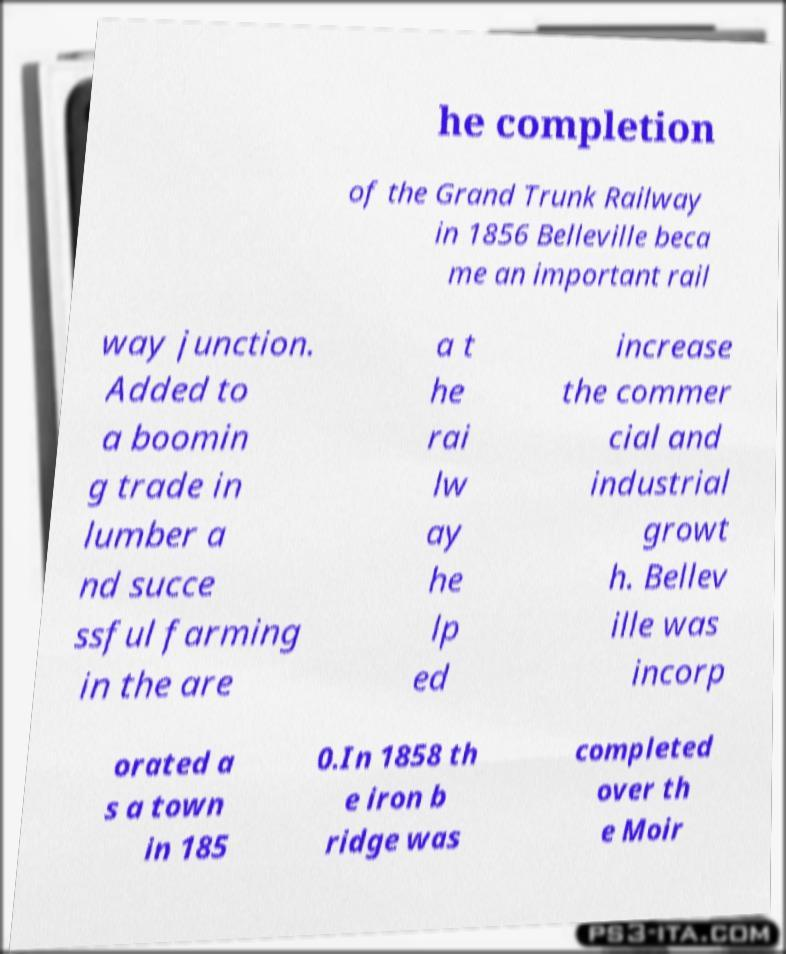Could you assist in decoding the text presented in this image and type it out clearly? he completion of the Grand Trunk Railway in 1856 Belleville beca me an important rail way junction. Added to a boomin g trade in lumber a nd succe ssful farming in the are a t he rai lw ay he lp ed increase the commer cial and industrial growt h. Bellev ille was incorp orated a s a town in 185 0.In 1858 th e iron b ridge was completed over th e Moir 